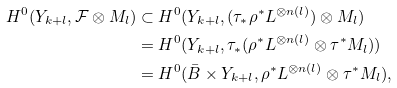Convert formula to latex. <formula><loc_0><loc_0><loc_500><loc_500>H ^ { 0 } ( Y _ { k + l } , \mathcal { F } \otimes M _ { l } ) & \subset H ^ { 0 } ( Y _ { k + l } , ( \tau _ { * } \rho ^ { * } L ^ { \otimes n ( l ) } ) \otimes M _ { l } ) \\ & = H ^ { 0 } ( Y _ { k + l } , \tau _ { * } ( \rho ^ { * } L ^ { \otimes n ( l ) } \otimes \tau ^ { * } M _ { l } ) ) \\ & = H ^ { 0 } ( \bar { B } \times Y _ { k + l } , \rho ^ { * } L ^ { \otimes n ( l ) } \otimes \tau ^ { * } M _ { l } ) ,</formula> 